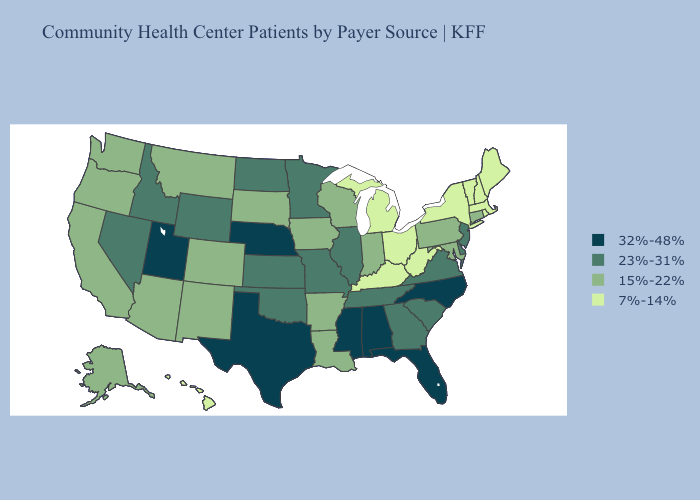What is the highest value in the USA?
Write a very short answer. 32%-48%. What is the highest value in states that border South Dakota?
Answer briefly. 32%-48%. Name the states that have a value in the range 32%-48%?
Give a very brief answer. Alabama, Florida, Mississippi, Nebraska, North Carolina, Texas, Utah. Name the states that have a value in the range 32%-48%?
Write a very short answer. Alabama, Florida, Mississippi, Nebraska, North Carolina, Texas, Utah. What is the value of Nevada?
Quick response, please. 23%-31%. What is the value of North Carolina?
Concise answer only. 32%-48%. Does Hawaii have a lower value than Florida?
Answer briefly. Yes. Does Iowa have the lowest value in the MidWest?
Short answer required. No. Which states have the lowest value in the USA?
Quick response, please. Hawaii, Kentucky, Maine, Massachusetts, Michigan, New Hampshire, New York, Ohio, Rhode Island, Vermont, West Virginia. What is the value of Vermont?
Short answer required. 7%-14%. Does California have the same value as Kentucky?
Write a very short answer. No. What is the highest value in states that border Missouri?
Give a very brief answer. 32%-48%. What is the highest value in the South ?
Keep it brief. 32%-48%. Does Florida have the same value as Texas?
Quick response, please. Yes. What is the value of Louisiana?
Answer briefly. 15%-22%. 